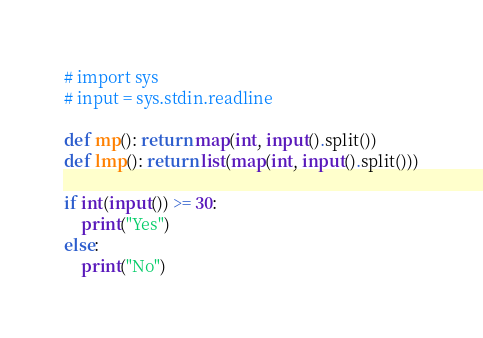Convert code to text. <code><loc_0><loc_0><loc_500><loc_500><_Python_># import sys
# input = sys.stdin.readline

def mp(): return map(int, input().split())
def lmp(): return list(map(int, input().split()))

if int(input()) >= 30:
    print("Yes")
else:
    print("No")


</code> 